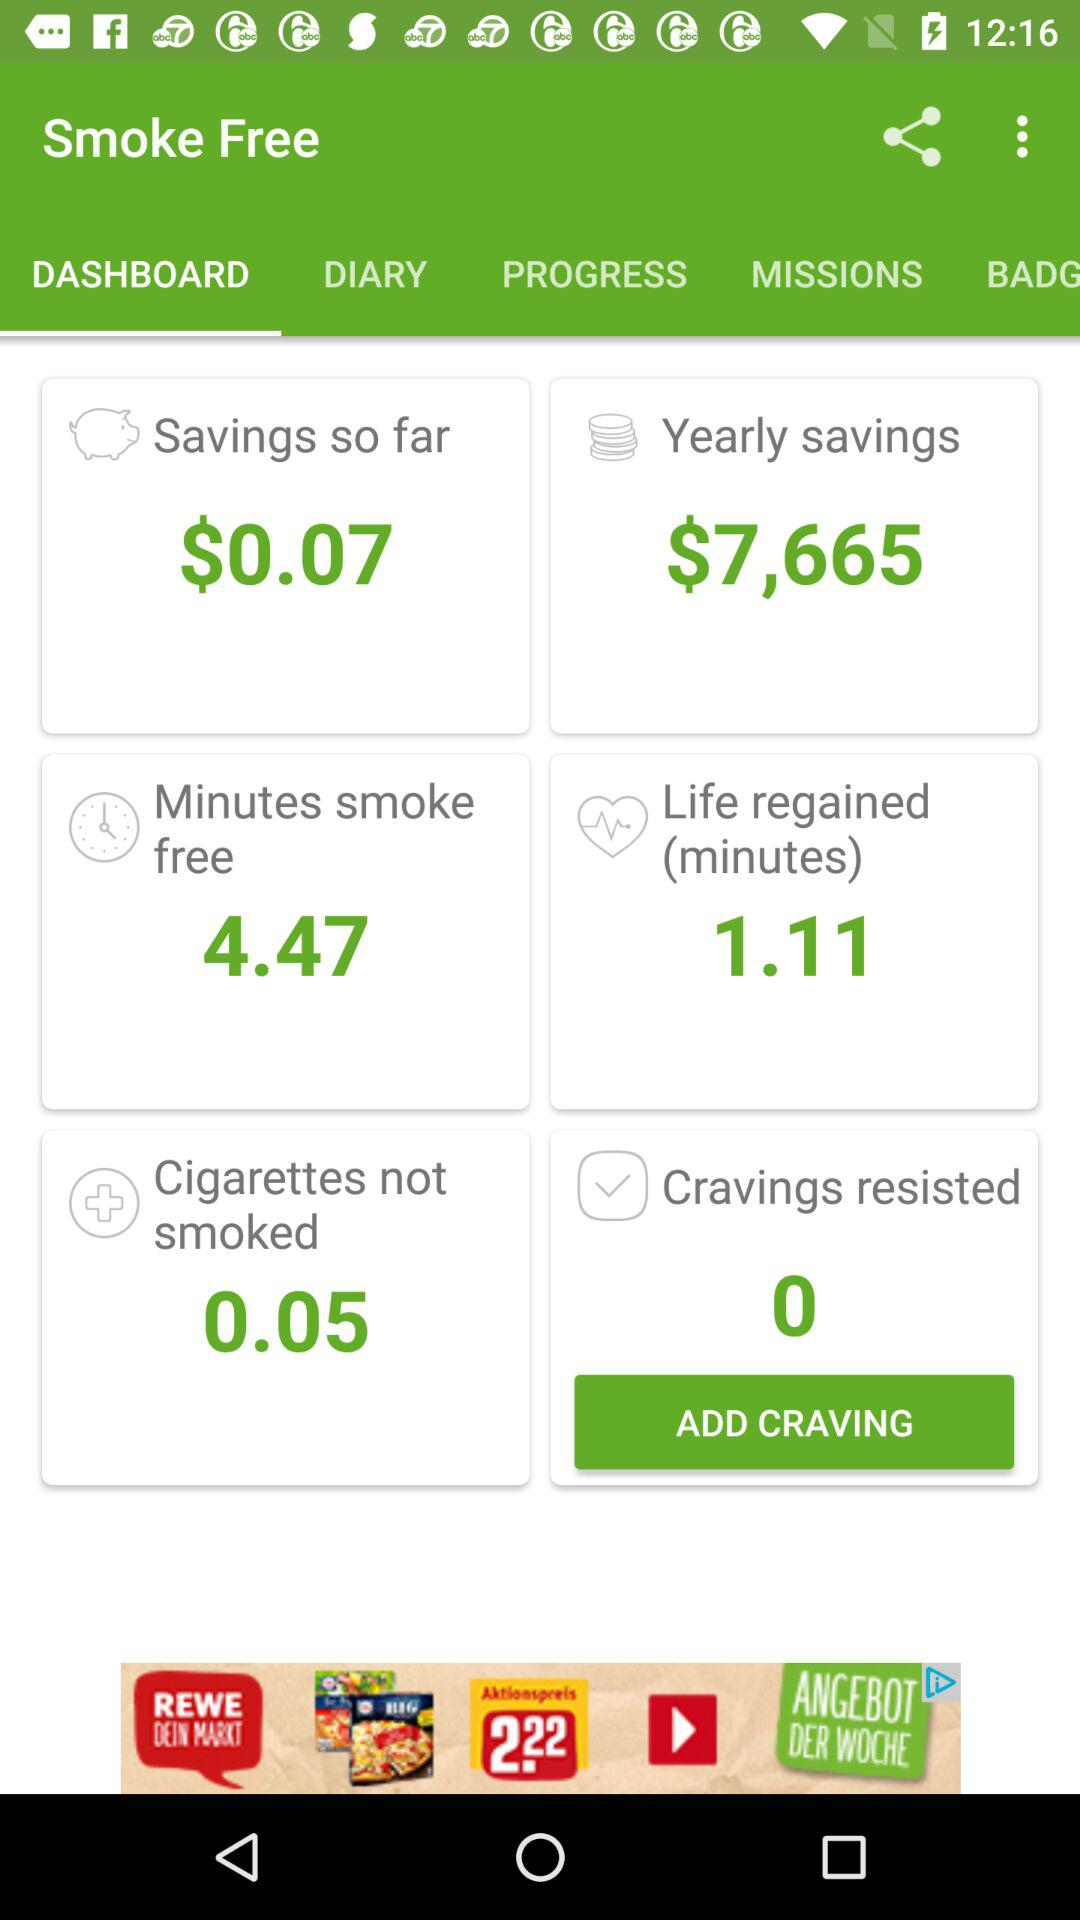What is the yearly saving amount? The yearly savings amount is $7,665. 